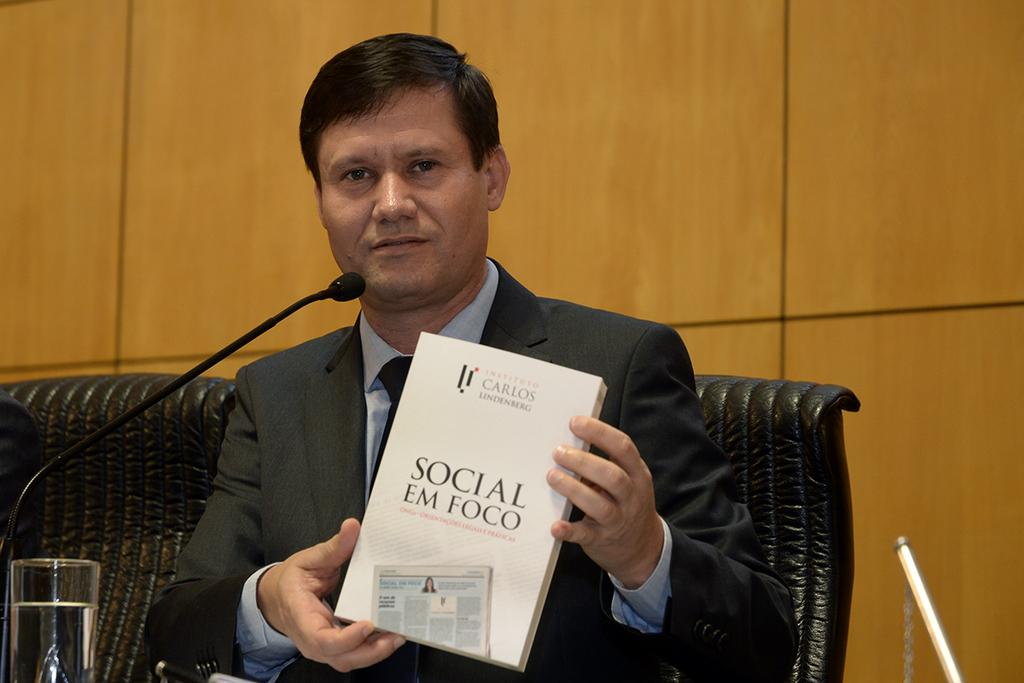<image>
Describe the image concisely. A man holds a book up that is titled Social Em Foco. 